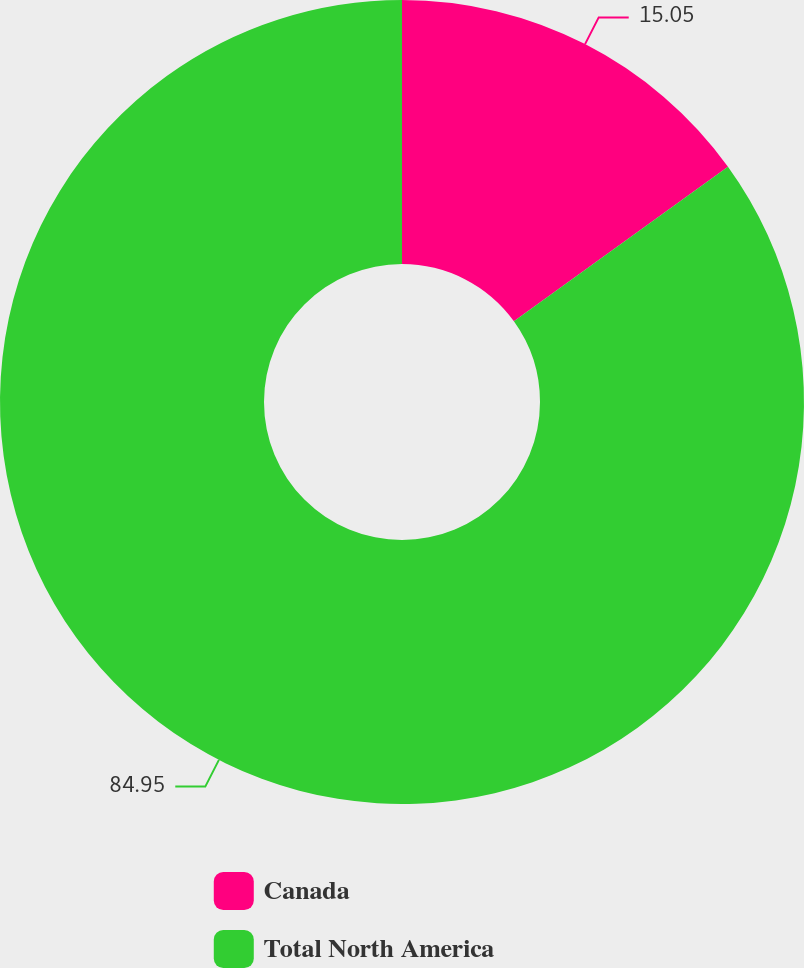Convert chart to OTSL. <chart><loc_0><loc_0><loc_500><loc_500><pie_chart><fcel>Canada<fcel>Total North America<nl><fcel>15.05%<fcel>84.95%<nl></chart> 